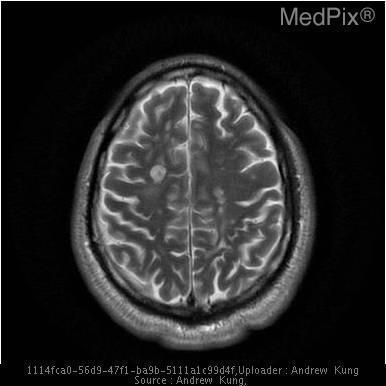What is abnormal about the image?
Short answer required. White matter plaques. Is gray or white matter highlighted in this image?
Short answer required. Gray matter. Which is highlighted in this image, white or gray matter?
Answer briefly. Gray matter. What side is the lesion located on?
Write a very short answer. Right. Where is the lesion?
Quick response, please. Right. Is the lesion located in gray or white matter?
Be succinct. White matter. Is the lesion seen in the gray or white matter?
Quick response, please. White matter. 